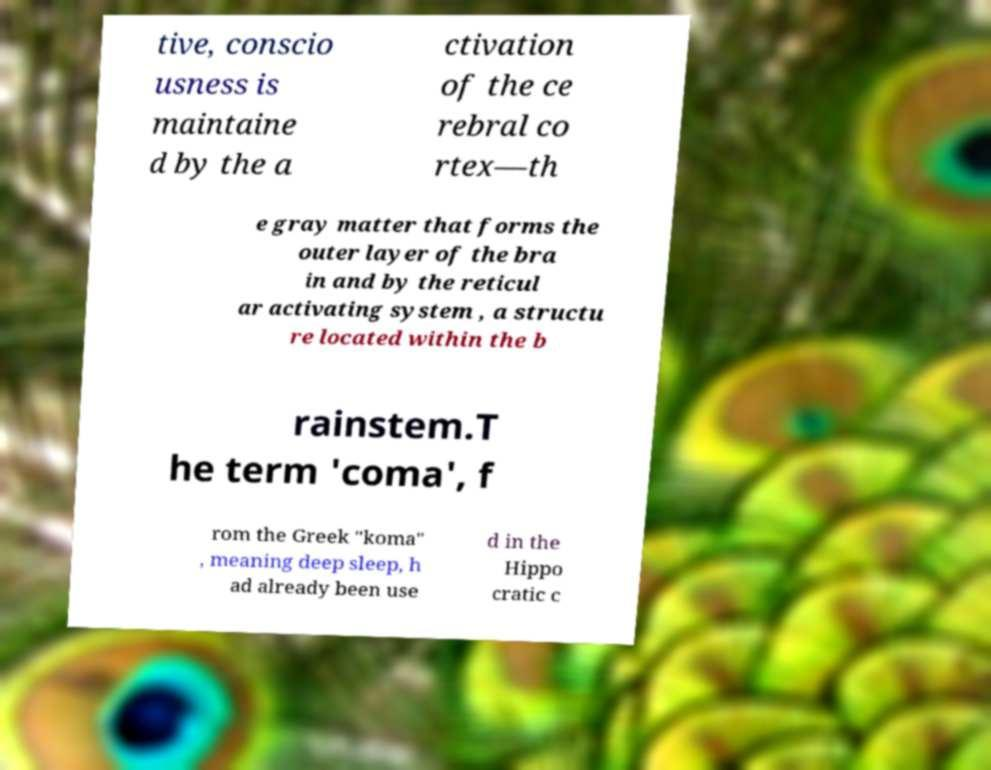I need the written content from this picture converted into text. Can you do that? tive, conscio usness is maintaine d by the a ctivation of the ce rebral co rtex—th e gray matter that forms the outer layer of the bra in and by the reticul ar activating system , a structu re located within the b rainstem.T he term 'coma', f rom the Greek "koma" , meaning deep sleep, h ad already been use d in the Hippo cratic c 